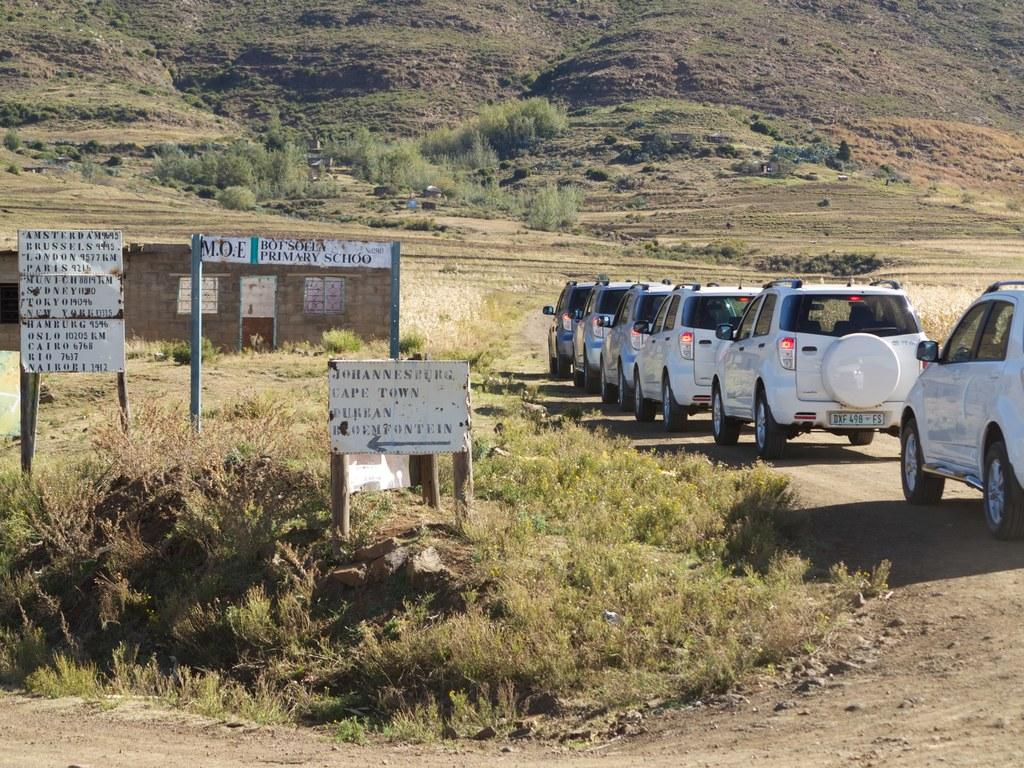What types of objects can be seen in the image? There are vehicles, poles, and a house in the image. What is visible on the ground in the image? The ground is visible in the image, and there is grass on it. Are there any plants in the image? Yes, there are plants in the image. What else can be seen on the ground in the image? There are boards with text in the image. How many leaves can be seen on the giraffe in the image? There is no giraffe present in the image, so there are no leaves to count. What type of trail can be seen in the image? There is no trail visible in the image. 